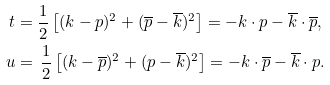<formula> <loc_0><loc_0><loc_500><loc_500>t & = \frac { 1 } { 2 } \left [ ( k - p ) ^ { 2 } + ( \overline { p } - \overline { k } ) ^ { 2 } \right ] = - k \cdot p - \overline { k } \cdot \overline { p } , \\ u & = \, \frac { 1 } { 2 } \left [ ( k - \overline { p } ) ^ { 2 } + ( p - \overline { k } ) ^ { 2 } \right ] = - k \cdot \overline { p } - \overline { k } \cdot p .</formula> 